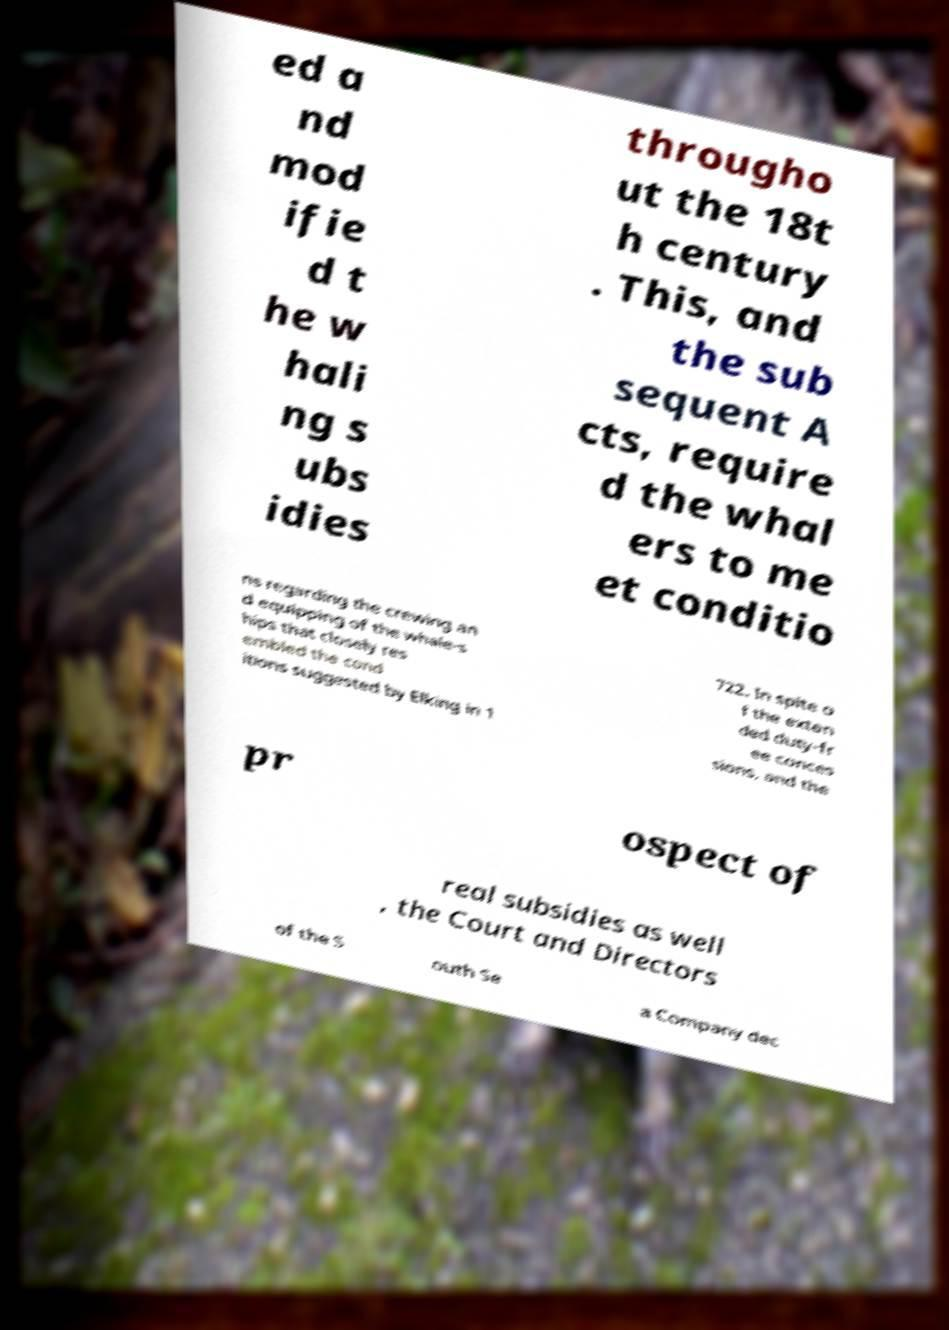Could you assist in decoding the text presented in this image and type it out clearly? ed a nd mod ifie d t he w hali ng s ubs idies througho ut the 18t h century . This, and the sub sequent A cts, require d the whal ers to me et conditio ns regarding the crewing an d equipping of the whale-s hips that closely res embled the cond itions suggested by Elking in 1 722. In spite o f the exten ded duty-fr ee conces sions, and the pr ospect of real subsidies as well , the Court and Directors of the S outh Se a Company dec 